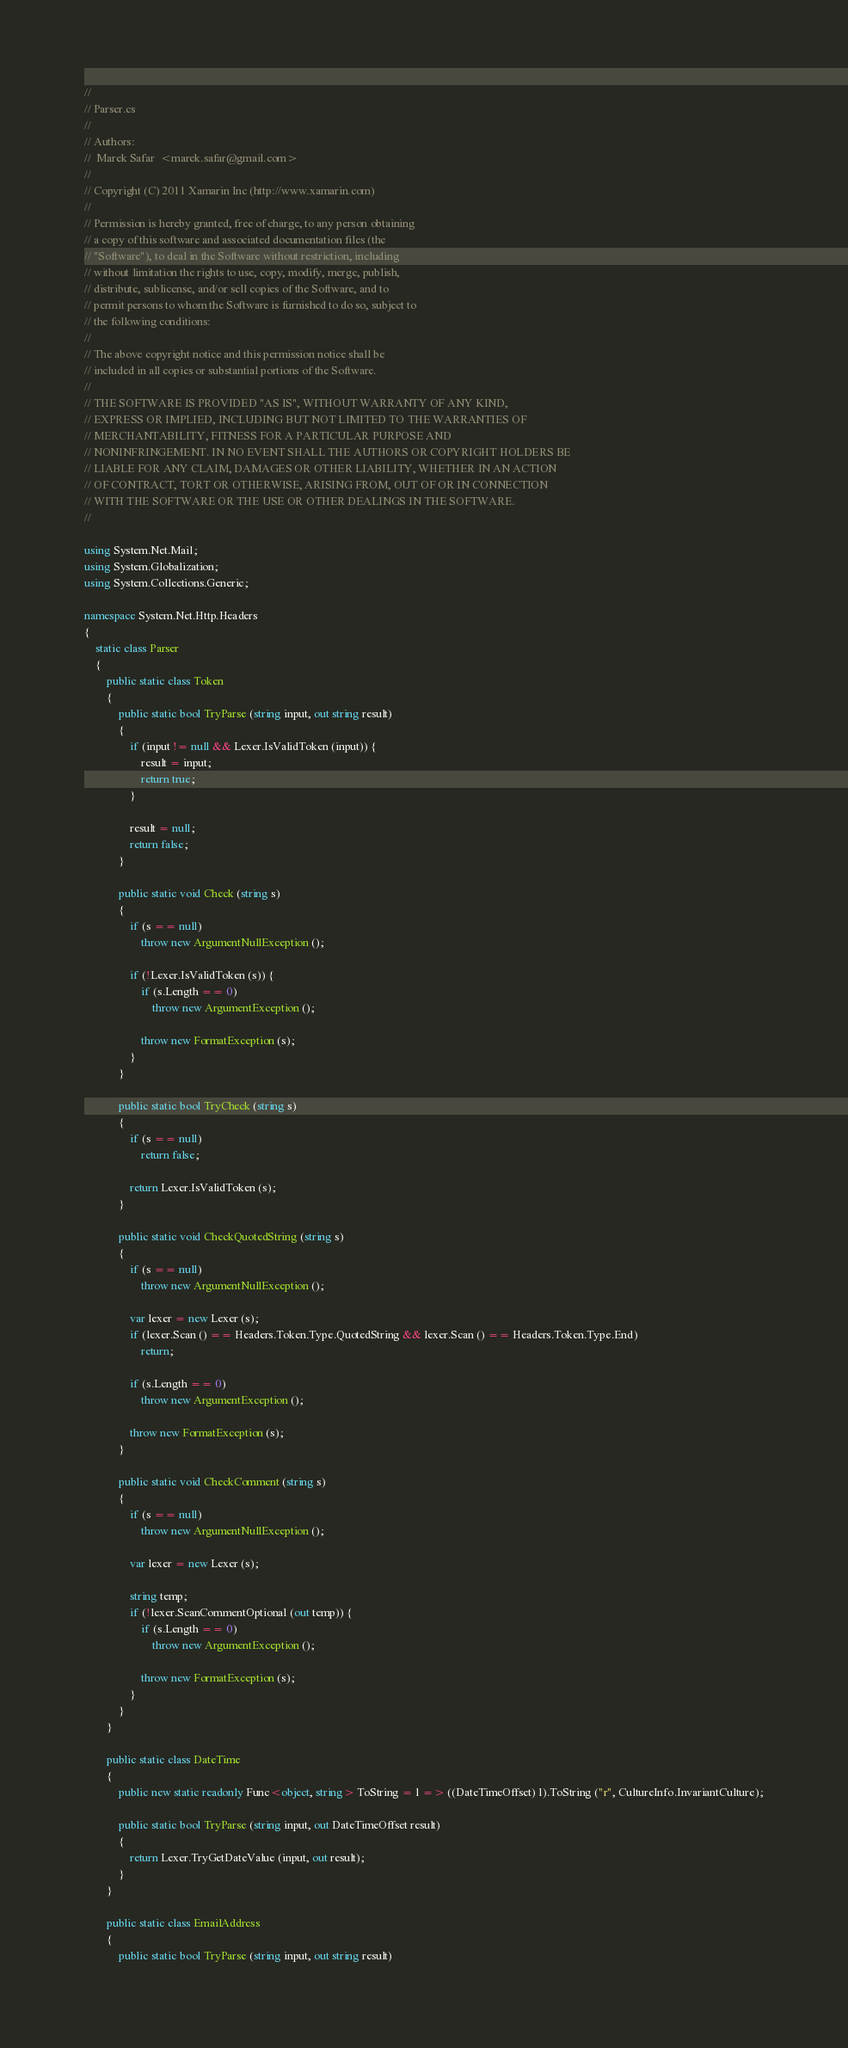Convert code to text. <code><loc_0><loc_0><loc_500><loc_500><_C#_>//
// Parser.cs
//
// Authors:
//	Marek Safar  <marek.safar@gmail.com>
//
// Copyright (C) 2011 Xamarin Inc (http://www.xamarin.com)
//
// Permission is hereby granted, free of charge, to any person obtaining
// a copy of this software and associated documentation files (the
// "Software"), to deal in the Software without restriction, including
// without limitation the rights to use, copy, modify, merge, publish,
// distribute, sublicense, and/or sell copies of the Software, and to
// permit persons to whom the Software is furnished to do so, subject to
// the following conditions:
//
// The above copyright notice and this permission notice shall be
// included in all copies or substantial portions of the Software.
//
// THE SOFTWARE IS PROVIDED "AS IS", WITHOUT WARRANTY OF ANY KIND,
// EXPRESS OR IMPLIED, INCLUDING BUT NOT LIMITED TO THE WARRANTIES OF
// MERCHANTABILITY, FITNESS FOR A PARTICULAR PURPOSE AND
// NONINFRINGEMENT. IN NO EVENT SHALL THE AUTHORS OR COPYRIGHT HOLDERS BE
// LIABLE FOR ANY CLAIM, DAMAGES OR OTHER LIABILITY, WHETHER IN AN ACTION
// OF CONTRACT, TORT OR OTHERWISE, ARISING FROM, OUT OF OR IN CONNECTION
// WITH THE SOFTWARE OR THE USE OR OTHER DEALINGS IN THE SOFTWARE.
//

using System.Net.Mail;
using System.Globalization;
using System.Collections.Generic;

namespace System.Net.Http.Headers
{
	static class Parser
	{
		public static class Token
		{
			public static bool TryParse (string input, out string result)
			{
				if (input != null && Lexer.IsValidToken (input)) {
					result = input;
					return true;
				}

				result = null;
				return false;
			}

			public static void Check (string s)
			{
				if (s == null)
					throw new ArgumentNullException ();

				if (!Lexer.IsValidToken (s)) {
					if (s.Length == 0)
						throw new ArgumentException ();

					throw new FormatException (s);
				}
			}

			public static bool TryCheck (string s)
			{
				if (s == null)
					return false;

				return Lexer.IsValidToken (s);
			}

			public static void CheckQuotedString (string s)
			{
				if (s == null)
					throw new ArgumentNullException ();

				var lexer = new Lexer (s);
				if (lexer.Scan () == Headers.Token.Type.QuotedString && lexer.Scan () == Headers.Token.Type.End)
					return;

				if (s.Length == 0)
					throw new ArgumentException ();

				throw new FormatException (s);
			}

			public static void CheckComment (string s)
			{
				if (s == null)
					throw new ArgumentNullException ();

				var lexer = new Lexer (s);

				string temp;
				if (!lexer.ScanCommentOptional (out temp)) {
					if (s.Length == 0)
						throw new ArgumentException ();

					throw new FormatException (s);
				}
			}
		}

		public static class DateTime
		{
			public new static readonly Func<object, string> ToString = l => ((DateTimeOffset) l).ToString ("r", CultureInfo.InvariantCulture);
			
			public static bool TryParse (string input, out DateTimeOffset result)
			{
				return Lexer.TryGetDateValue (input, out result);
			}
		}

		public static class EmailAddress
		{
			public static bool TryParse (string input, out string result)</code> 